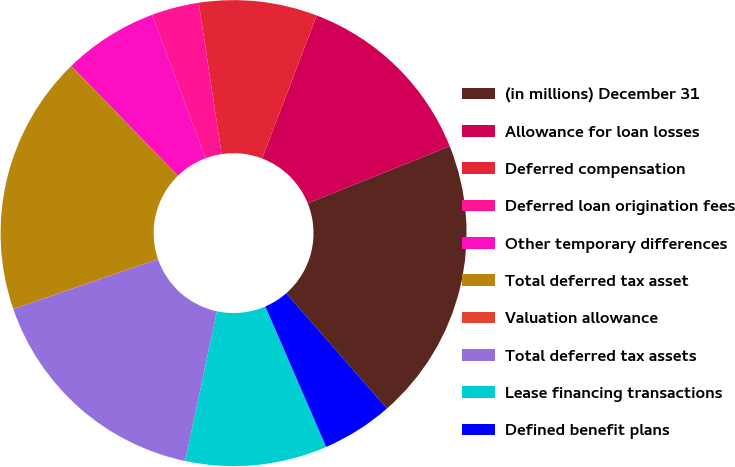<chart> <loc_0><loc_0><loc_500><loc_500><pie_chart><fcel>(in millions) December 31<fcel>Allowance for loan losses<fcel>Deferred compensation<fcel>Deferred loan origination fees<fcel>Other temporary differences<fcel>Total deferred tax asset<fcel>Valuation allowance<fcel>Total deferred tax assets<fcel>Lease financing transactions<fcel>Defined benefit plans<nl><fcel>19.65%<fcel>13.11%<fcel>8.2%<fcel>3.3%<fcel>6.57%<fcel>18.01%<fcel>0.02%<fcel>16.38%<fcel>9.84%<fcel>4.93%<nl></chart> 